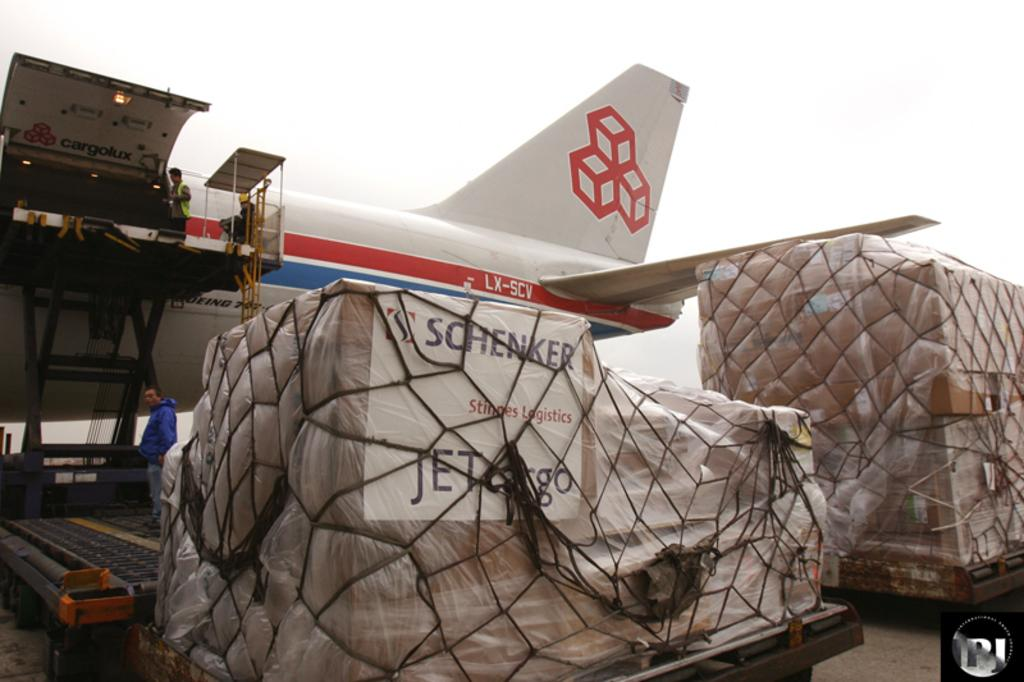<image>
Give a short and clear explanation of the subsequent image. Netted cargo is ready to be loaded onto plane LX-SCV. 